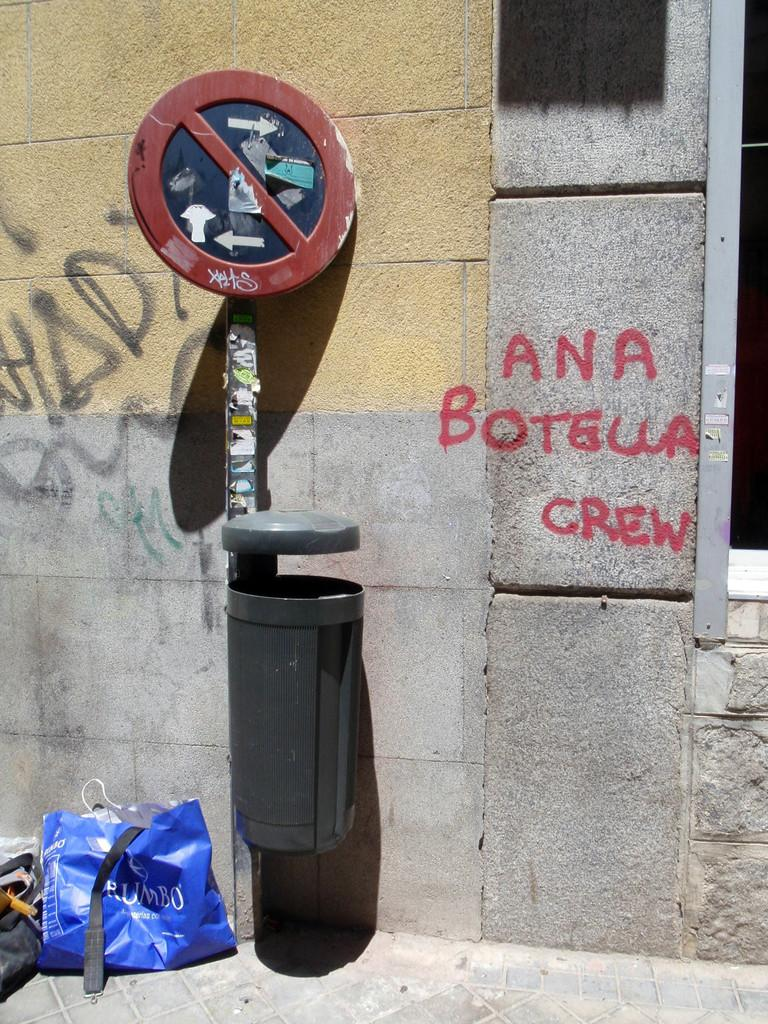<image>
Offer a succinct explanation of the picture presented. The Ana Botella crew tagged the building next to the trash can. 